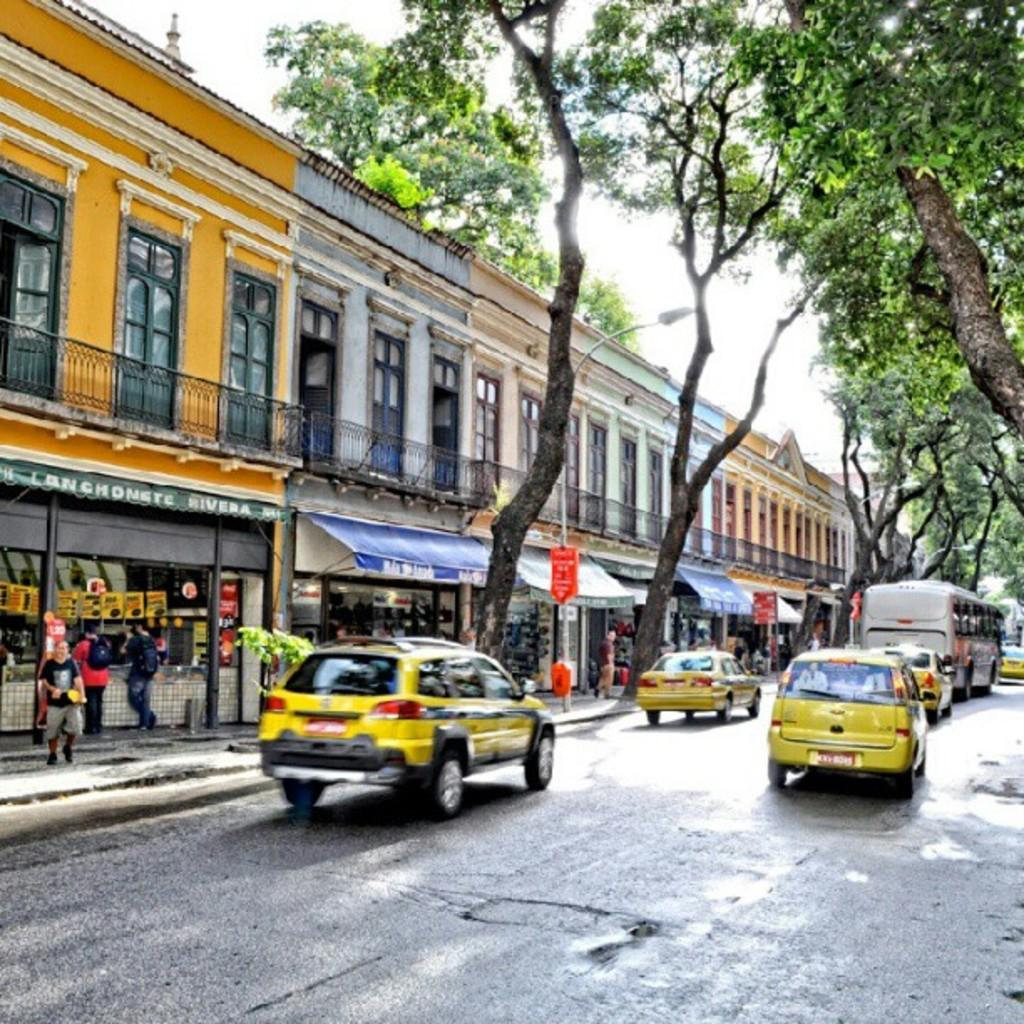Provide a one-sentence caption for the provided image. Among several stores lining a moderately busy street, one of the canopies contains the word Rivera. 